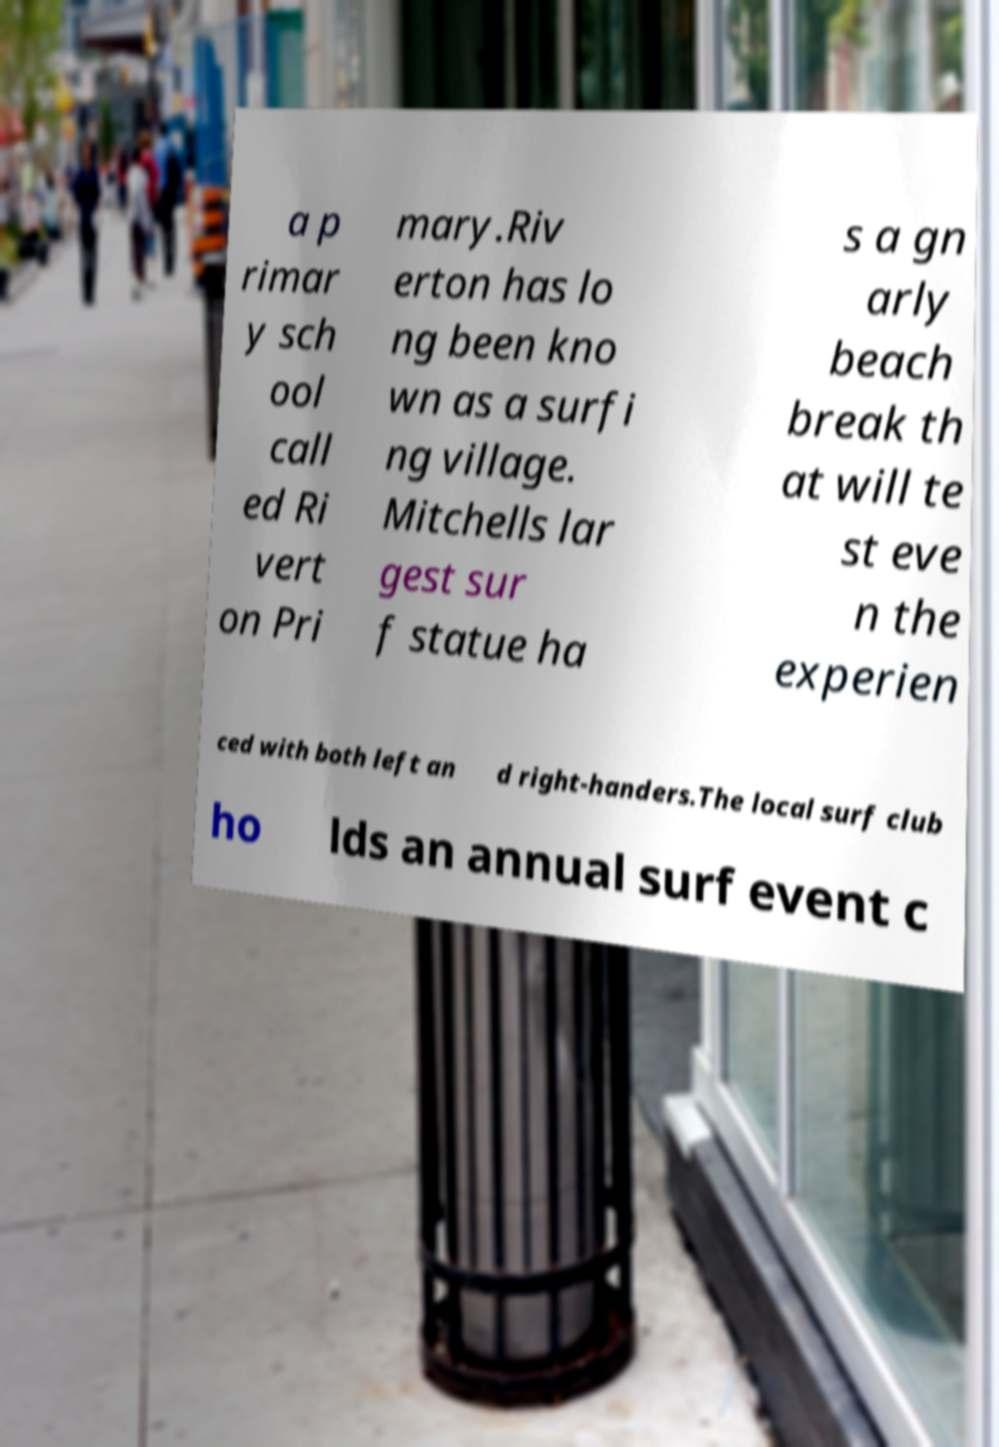Can you accurately transcribe the text from the provided image for me? a p rimar y sch ool call ed Ri vert on Pri mary.Riv erton has lo ng been kno wn as a surfi ng village. Mitchells lar gest sur f statue ha s a gn arly beach break th at will te st eve n the experien ced with both left an d right-handers.The local surf club ho lds an annual surf event c 